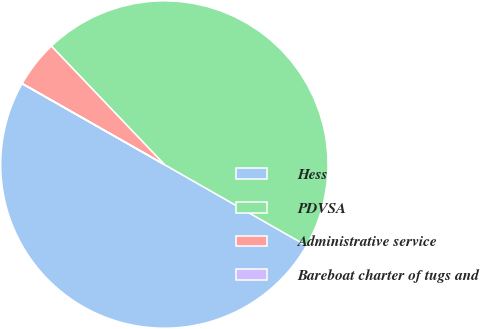Convert chart to OTSL. <chart><loc_0><loc_0><loc_500><loc_500><pie_chart><fcel>Hess<fcel>PDVSA<fcel>Administrative service<fcel>Bareboat charter of tugs and<nl><fcel>49.97%<fcel>45.38%<fcel>4.62%<fcel>0.03%<nl></chart> 